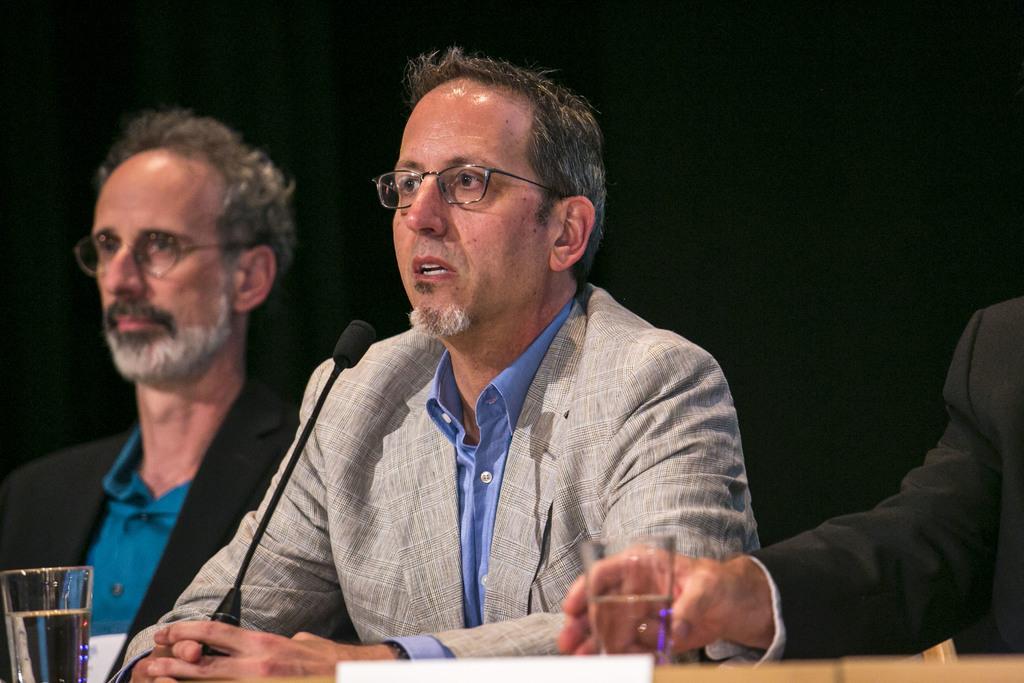Describe this image in one or two sentences. A person wearing white coat is sitting and speaking in front of a mic and there is also another person on either side of him and there is a table in front of them which has a glass of water in it. 